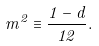Convert formula to latex. <formula><loc_0><loc_0><loc_500><loc_500>m ^ { 2 } \equiv \frac { 1 - d } { 1 2 } .</formula> 